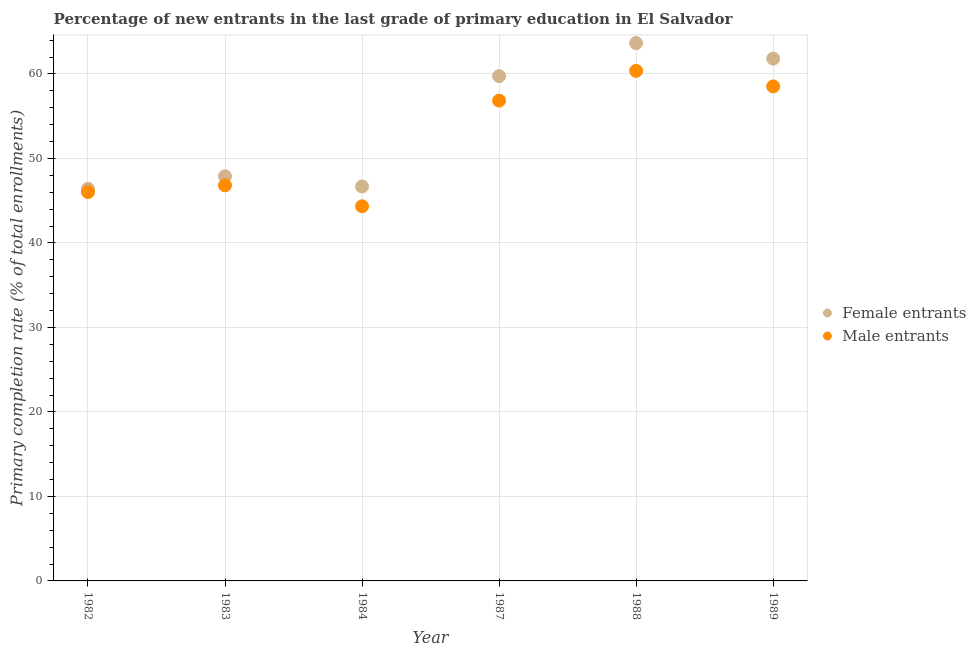How many different coloured dotlines are there?
Offer a terse response. 2. Is the number of dotlines equal to the number of legend labels?
Your answer should be compact. Yes. What is the primary completion rate of female entrants in 1982?
Your answer should be very brief. 46.41. Across all years, what is the maximum primary completion rate of female entrants?
Offer a terse response. 63.66. Across all years, what is the minimum primary completion rate of female entrants?
Your answer should be very brief. 46.41. In which year was the primary completion rate of female entrants maximum?
Provide a short and direct response. 1988. In which year was the primary completion rate of male entrants minimum?
Give a very brief answer. 1984. What is the total primary completion rate of male entrants in the graph?
Offer a terse response. 312.92. What is the difference between the primary completion rate of female entrants in 1987 and that in 1988?
Your answer should be compact. -3.92. What is the difference between the primary completion rate of female entrants in 1989 and the primary completion rate of male entrants in 1987?
Provide a short and direct response. 4.97. What is the average primary completion rate of female entrants per year?
Give a very brief answer. 54.37. In the year 1987, what is the difference between the primary completion rate of male entrants and primary completion rate of female entrants?
Provide a short and direct response. -2.89. In how many years, is the primary completion rate of female entrants greater than 56 %?
Offer a very short reply. 3. What is the ratio of the primary completion rate of male entrants in 1988 to that in 1989?
Offer a terse response. 1.03. Is the difference between the primary completion rate of male entrants in 1988 and 1989 greater than the difference between the primary completion rate of female entrants in 1988 and 1989?
Provide a short and direct response. No. What is the difference between the highest and the second highest primary completion rate of female entrants?
Your answer should be very brief. 1.85. What is the difference between the highest and the lowest primary completion rate of male entrants?
Give a very brief answer. 16.02. Is the primary completion rate of male entrants strictly less than the primary completion rate of female entrants over the years?
Offer a very short reply. Yes. What is the difference between two consecutive major ticks on the Y-axis?
Your answer should be compact. 10. Does the graph contain grids?
Make the answer very short. Yes. How many legend labels are there?
Provide a succinct answer. 2. What is the title of the graph?
Provide a short and direct response. Percentage of new entrants in the last grade of primary education in El Salvador. Does "Goods" appear as one of the legend labels in the graph?
Your response must be concise. No. What is the label or title of the Y-axis?
Keep it short and to the point. Primary completion rate (% of total enrollments). What is the Primary completion rate (% of total enrollments) of Female entrants in 1982?
Provide a succinct answer. 46.41. What is the Primary completion rate (% of total enrollments) in Male entrants in 1982?
Your response must be concise. 46.02. What is the Primary completion rate (% of total enrollments) of Female entrants in 1983?
Offer a terse response. 47.89. What is the Primary completion rate (% of total enrollments) in Male entrants in 1983?
Offer a terse response. 46.82. What is the Primary completion rate (% of total enrollments) in Female entrants in 1984?
Make the answer very short. 46.68. What is the Primary completion rate (% of total enrollments) of Male entrants in 1984?
Your answer should be very brief. 44.34. What is the Primary completion rate (% of total enrollments) in Female entrants in 1987?
Your answer should be compact. 59.74. What is the Primary completion rate (% of total enrollments) in Male entrants in 1987?
Give a very brief answer. 56.85. What is the Primary completion rate (% of total enrollments) of Female entrants in 1988?
Provide a short and direct response. 63.66. What is the Primary completion rate (% of total enrollments) of Male entrants in 1988?
Offer a very short reply. 60.36. What is the Primary completion rate (% of total enrollments) in Female entrants in 1989?
Ensure brevity in your answer.  61.81. What is the Primary completion rate (% of total enrollments) in Male entrants in 1989?
Provide a short and direct response. 58.53. Across all years, what is the maximum Primary completion rate (% of total enrollments) of Female entrants?
Your answer should be very brief. 63.66. Across all years, what is the maximum Primary completion rate (% of total enrollments) of Male entrants?
Provide a succinct answer. 60.36. Across all years, what is the minimum Primary completion rate (% of total enrollments) of Female entrants?
Keep it short and to the point. 46.41. Across all years, what is the minimum Primary completion rate (% of total enrollments) in Male entrants?
Your answer should be compact. 44.34. What is the total Primary completion rate (% of total enrollments) in Female entrants in the graph?
Ensure brevity in your answer.  326.21. What is the total Primary completion rate (% of total enrollments) of Male entrants in the graph?
Provide a succinct answer. 312.92. What is the difference between the Primary completion rate (% of total enrollments) in Female entrants in 1982 and that in 1983?
Keep it short and to the point. -1.48. What is the difference between the Primary completion rate (% of total enrollments) of Male entrants in 1982 and that in 1983?
Offer a very short reply. -0.8. What is the difference between the Primary completion rate (% of total enrollments) in Female entrants in 1982 and that in 1984?
Offer a terse response. -0.27. What is the difference between the Primary completion rate (% of total enrollments) of Male entrants in 1982 and that in 1984?
Offer a very short reply. 1.68. What is the difference between the Primary completion rate (% of total enrollments) in Female entrants in 1982 and that in 1987?
Your response must be concise. -13.33. What is the difference between the Primary completion rate (% of total enrollments) of Male entrants in 1982 and that in 1987?
Your answer should be very brief. -10.83. What is the difference between the Primary completion rate (% of total enrollments) in Female entrants in 1982 and that in 1988?
Your answer should be very brief. -17.25. What is the difference between the Primary completion rate (% of total enrollments) of Male entrants in 1982 and that in 1988?
Provide a succinct answer. -14.34. What is the difference between the Primary completion rate (% of total enrollments) in Female entrants in 1982 and that in 1989?
Your answer should be compact. -15.4. What is the difference between the Primary completion rate (% of total enrollments) in Male entrants in 1982 and that in 1989?
Offer a very short reply. -12.51. What is the difference between the Primary completion rate (% of total enrollments) of Female entrants in 1983 and that in 1984?
Make the answer very short. 1.21. What is the difference between the Primary completion rate (% of total enrollments) in Male entrants in 1983 and that in 1984?
Keep it short and to the point. 2.48. What is the difference between the Primary completion rate (% of total enrollments) of Female entrants in 1983 and that in 1987?
Make the answer very short. -11.85. What is the difference between the Primary completion rate (% of total enrollments) in Male entrants in 1983 and that in 1987?
Your response must be concise. -10.03. What is the difference between the Primary completion rate (% of total enrollments) in Female entrants in 1983 and that in 1988?
Provide a succinct answer. -15.77. What is the difference between the Primary completion rate (% of total enrollments) of Male entrants in 1983 and that in 1988?
Make the answer very short. -13.54. What is the difference between the Primary completion rate (% of total enrollments) of Female entrants in 1983 and that in 1989?
Provide a short and direct response. -13.92. What is the difference between the Primary completion rate (% of total enrollments) in Male entrants in 1983 and that in 1989?
Offer a terse response. -11.71. What is the difference between the Primary completion rate (% of total enrollments) of Female entrants in 1984 and that in 1987?
Your answer should be compact. -13.06. What is the difference between the Primary completion rate (% of total enrollments) of Male entrants in 1984 and that in 1987?
Your answer should be very brief. -12.51. What is the difference between the Primary completion rate (% of total enrollments) in Female entrants in 1984 and that in 1988?
Ensure brevity in your answer.  -16.98. What is the difference between the Primary completion rate (% of total enrollments) of Male entrants in 1984 and that in 1988?
Keep it short and to the point. -16.02. What is the difference between the Primary completion rate (% of total enrollments) in Female entrants in 1984 and that in 1989?
Give a very brief answer. -15.13. What is the difference between the Primary completion rate (% of total enrollments) of Male entrants in 1984 and that in 1989?
Offer a very short reply. -14.19. What is the difference between the Primary completion rate (% of total enrollments) of Female entrants in 1987 and that in 1988?
Offer a terse response. -3.92. What is the difference between the Primary completion rate (% of total enrollments) of Male entrants in 1987 and that in 1988?
Give a very brief answer. -3.52. What is the difference between the Primary completion rate (% of total enrollments) of Female entrants in 1987 and that in 1989?
Keep it short and to the point. -2.07. What is the difference between the Primary completion rate (% of total enrollments) in Male entrants in 1987 and that in 1989?
Your answer should be compact. -1.68. What is the difference between the Primary completion rate (% of total enrollments) of Female entrants in 1988 and that in 1989?
Your answer should be very brief. 1.85. What is the difference between the Primary completion rate (% of total enrollments) of Male entrants in 1988 and that in 1989?
Offer a very short reply. 1.84. What is the difference between the Primary completion rate (% of total enrollments) in Female entrants in 1982 and the Primary completion rate (% of total enrollments) in Male entrants in 1983?
Your answer should be compact. -0.41. What is the difference between the Primary completion rate (% of total enrollments) in Female entrants in 1982 and the Primary completion rate (% of total enrollments) in Male entrants in 1984?
Ensure brevity in your answer.  2.07. What is the difference between the Primary completion rate (% of total enrollments) of Female entrants in 1982 and the Primary completion rate (% of total enrollments) of Male entrants in 1987?
Give a very brief answer. -10.43. What is the difference between the Primary completion rate (% of total enrollments) in Female entrants in 1982 and the Primary completion rate (% of total enrollments) in Male entrants in 1988?
Ensure brevity in your answer.  -13.95. What is the difference between the Primary completion rate (% of total enrollments) of Female entrants in 1982 and the Primary completion rate (% of total enrollments) of Male entrants in 1989?
Make the answer very short. -12.11. What is the difference between the Primary completion rate (% of total enrollments) of Female entrants in 1983 and the Primary completion rate (% of total enrollments) of Male entrants in 1984?
Make the answer very short. 3.55. What is the difference between the Primary completion rate (% of total enrollments) of Female entrants in 1983 and the Primary completion rate (% of total enrollments) of Male entrants in 1987?
Ensure brevity in your answer.  -8.95. What is the difference between the Primary completion rate (% of total enrollments) in Female entrants in 1983 and the Primary completion rate (% of total enrollments) in Male entrants in 1988?
Ensure brevity in your answer.  -12.47. What is the difference between the Primary completion rate (% of total enrollments) of Female entrants in 1983 and the Primary completion rate (% of total enrollments) of Male entrants in 1989?
Make the answer very short. -10.64. What is the difference between the Primary completion rate (% of total enrollments) of Female entrants in 1984 and the Primary completion rate (% of total enrollments) of Male entrants in 1987?
Offer a very short reply. -10.16. What is the difference between the Primary completion rate (% of total enrollments) in Female entrants in 1984 and the Primary completion rate (% of total enrollments) in Male entrants in 1988?
Your response must be concise. -13.68. What is the difference between the Primary completion rate (% of total enrollments) in Female entrants in 1984 and the Primary completion rate (% of total enrollments) in Male entrants in 1989?
Offer a very short reply. -11.84. What is the difference between the Primary completion rate (% of total enrollments) in Female entrants in 1987 and the Primary completion rate (% of total enrollments) in Male entrants in 1988?
Your answer should be very brief. -0.62. What is the difference between the Primary completion rate (% of total enrollments) in Female entrants in 1987 and the Primary completion rate (% of total enrollments) in Male entrants in 1989?
Your answer should be very brief. 1.21. What is the difference between the Primary completion rate (% of total enrollments) in Female entrants in 1988 and the Primary completion rate (% of total enrollments) in Male entrants in 1989?
Your answer should be compact. 5.13. What is the average Primary completion rate (% of total enrollments) in Female entrants per year?
Offer a very short reply. 54.37. What is the average Primary completion rate (% of total enrollments) in Male entrants per year?
Provide a succinct answer. 52.15. In the year 1982, what is the difference between the Primary completion rate (% of total enrollments) of Female entrants and Primary completion rate (% of total enrollments) of Male entrants?
Provide a succinct answer. 0.39. In the year 1983, what is the difference between the Primary completion rate (% of total enrollments) of Female entrants and Primary completion rate (% of total enrollments) of Male entrants?
Your response must be concise. 1.07. In the year 1984, what is the difference between the Primary completion rate (% of total enrollments) of Female entrants and Primary completion rate (% of total enrollments) of Male entrants?
Your answer should be compact. 2.34. In the year 1987, what is the difference between the Primary completion rate (% of total enrollments) of Female entrants and Primary completion rate (% of total enrollments) of Male entrants?
Offer a very short reply. 2.89. In the year 1988, what is the difference between the Primary completion rate (% of total enrollments) of Female entrants and Primary completion rate (% of total enrollments) of Male entrants?
Your answer should be very brief. 3.3. In the year 1989, what is the difference between the Primary completion rate (% of total enrollments) in Female entrants and Primary completion rate (% of total enrollments) in Male entrants?
Provide a short and direct response. 3.29. What is the ratio of the Primary completion rate (% of total enrollments) of Female entrants in 1982 to that in 1983?
Your answer should be very brief. 0.97. What is the ratio of the Primary completion rate (% of total enrollments) in Male entrants in 1982 to that in 1983?
Make the answer very short. 0.98. What is the ratio of the Primary completion rate (% of total enrollments) of Female entrants in 1982 to that in 1984?
Offer a terse response. 0.99. What is the ratio of the Primary completion rate (% of total enrollments) of Male entrants in 1982 to that in 1984?
Offer a very short reply. 1.04. What is the ratio of the Primary completion rate (% of total enrollments) of Female entrants in 1982 to that in 1987?
Offer a very short reply. 0.78. What is the ratio of the Primary completion rate (% of total enrollments) of Male entrants in 1982 to that in 1987?
Make the answer very short. 0.81. What is the ratio of the Primary completion rate (% of total enrollments) in Female entrants in 1982 to that in 1988?
Your answer should be very brief. 0.73. What is the ratio of the Primary completion rate (% of total enrollments) in Male entrants in 1982 to that in 1988?
Give a very brief answer. 0.76. What is the ratio of the Primary completion rate (% of total enrollments) of Female entrants in 1982 to that in 1989?
Your answer should be very brief. 0.75. What is the ratio of the Primary completion rate (% of total enrollments) of Male entrants in 1982 to that in 1989?
Provide a short and direct response. 0.79. What is the ratio of the Primary completion rate (% of total enrollments) in Female entrants in 1983 to that in 1984?
Keep it short and to the point. 1.03. What is the ratio of the Primary completion rate (% of total enrollments) in Male entrants in 1983 to that in 1984?
Your answer should be very brief. 1.06. What is the ratio of the Primary completion rate (% of total enrollments) of Female entrants in 1983 to that in 1987?
Offer a very short reply. 0.8. What is the ratio of the Primary completion rate (% of total enrollments) of Male entrants in 1983 to that in 1987?
Offer a terse response. 0.82. What is the ratio of the Primary completion rate (% of total enrollments) in Female entrants in 1983 to that in 1988?
Provide a succinct answer. 0.75. What is the ratio of the Primary completion rate (% of total enrollments) in Male entrants in 1983 to that in 1988?
Ensure brevity in your answer.  0.78. What is the ratio of the Primary completion rate (% of total enrollments) of Female entrants in 1983 to that in 1989?
Offer a very short reply. 0.77. What is the ratio of the Primary completion rate (% of total enrollments) in Male entrants in 1983 to that in 1989?
Your response must be concise. 0.8. What is the ratio of the Primary completion rate (% of total enrollments) of Female entrants in 1984 to that in 1987?
Your answer should be compact. 0.78. What is the ratio of the Primary completion rate (% of total enrollments) in Male entrants in 1984 to that in 1987?
Provide a short and direct response. 0.78. What is the ratio of the Primary completion rate (% of total enrollments) in Female entrants in 1984 to that in 1988?
Provide a short and direct response. 0.73. What is the ratio of the Primary completion rate (% of total enrollments) in Male entrants in 1984 to that in 1988?
Offer a very short reply. 0.73. What is the ratio of the Primary completion rate (% of total enrollments) of Female entrants in 1984 to that in 1989?
Give a very brief answer. 0.76. What is the ratio of the Primary completion rate (% of total enrollments) in Male entrants in 1984 to that in 1989?
Provide a short and direct response. 0.76. What is the ratio of the Primary completion rate (% of total enrollments) of Female entrants in 1987 to that in 1988?
Keep it short and to the point. 0.94. What is the ratio of the Primary completion rate (% of total enrollments) of Male entrants in 1987 to that in 1988?
Offer a terse response. 0.94. What is the ratio of the Primary completion rate (% of total enrollments) in Female entrants in 1987 to that in 1989?
Offer a very short reply. 0.97. What is the ratio of the Primary completion rate (% of total enrollments) of Male entrants in 1987 to that in 1989?
Offer a terse response. 0.97. What is the ratio of the Primary completion rate (% of total enrollments) in Female entrants in 1988 to that in 1989?
Your answer should be compact. 1.03. What is the ratio of the Primary completion rate (% of total enrollments) in Male entrants in 1988 to that in 1989?
Your answer should be compact. 1.03. What is the difference between the highest and the second highest Primary completion rate (% of total enrollments) of Female entrants?
Your answer should be very brief. 1.85. What is the difference between the highest and the second highest Primary completion rate (% of total enrollments) of Male entrants?
Provide a short and direct response. 1.84. What is the difference between the highest and the lowest Primary completion rate (% of total enrollments) in Female entrants?
Provide a succinct answer. 17.25. What is the difference between the highest and the lowest Primary completion rate (% of total enrollments) in Male entrants?
Provide a short and direct response. 16.02. 